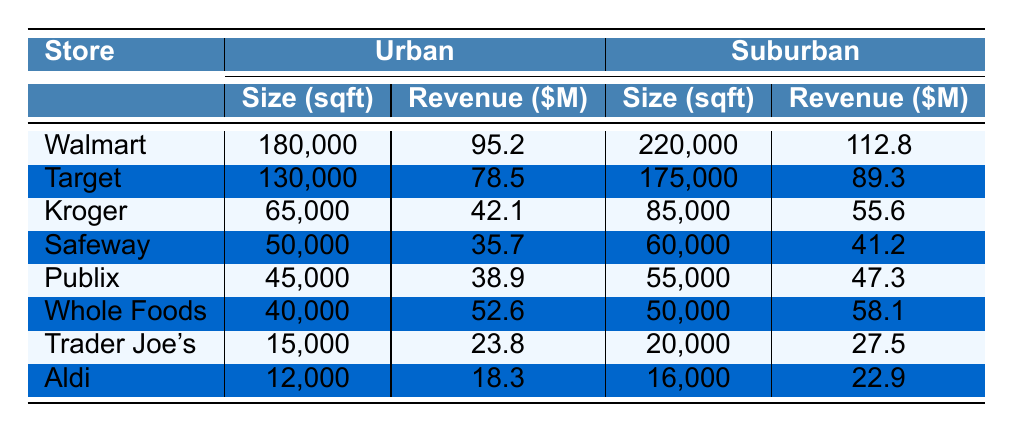What is the annual revenue of Walmart in an urban location? From the table, Walmart's annual revenue in an urban location is listed as 95.2 million dollars.
Answer: 95.2 million dollars What is the size of Target stores in suburban areas? The table shows that Target stores in suburban areas have a size of 175,000 square feet.
Answer: 175,000 square feet Which suburban store has the highest annual revenue? By examining the table, Walmart in suburban areas has the highest annual revenue of 112.8 million dollars compared to the other stores listed.
Answer: Walmart with 112.8 million dollars What is the difference in size between Kroger's urban and suburban stores? The size of Kroger's urban store is 65,000 square feet and the suburban store is 85,000 square feet. The difference is 85,000 - 65,000 = 20,000 square feet.
Answer: 20,000 square feet What is the average size of stores in urban locations? The sizes for the urban stores are: 180,000, 130,000, 65,000, 50,000, 45,000, 40,000, 15,000, and 12,000 square feet. Summing these gives 180,000 + 130,000 + 65,000 + 50,000 + 45,000 + 40,000 + 15,000 + 12,000 = 532,000 square feet. There are 8 stores, so the average size is 532,000 / 8 = 66,500 square feet.
Answer: 66,500 square feet Is there any store with the same size in both urban and suburban areas? By analyzing the table, no store has the same size listed for both locations; all values differ.
Answer: No Which store has the least annual revenue in urban areas? The table indicates that Aldi has the least annual revenue in urban areas at 18.3 million dollars.
Answer: Aldi with 18.3 million dollars What is the median store size in suburban areas? The sizes for suburban stores are 220,000, 175,000, 85,000, 60,000, 55,000, 50,000, 20,000, and 16,000 square feet. Arranging the sizes in ascending order gives: 16,000, 20,000, 50,000, 55,000, 60,000, 85,000, 175,000, 220,000. With an even number of entries, the median is the average of the 4th and 5th sizes: (55,000 + 60,000) / 2 = 57,500 square feet.
Answer: 57,500 square feet What is the total annual revenue from suburban stores? The revenues from suburban stores are 112.8, 89.3, 55.6, 41.2, 47.3, 58.1, 27.5, and 22.9 million dollars. Adding these gives 112.8 + 89.3 + 55.6 + 41.2 + 47.3 + 58.1 + 27.5 + 22.9 = 403.7 million dollars.
Answer: 403.7 million dollars Which urban store has the highest ratio of revenue to store size? The revenue-to-size ratios can be calculated as follows: Walmart: 95.2 / 180,000, Target: 78.5 / 130,000, Kroger: 42.1 / 65,000, Safeway: 35.7 / 50,000, Publix: 38.9 / 45,000, Whole Foods: 52.6 / 40,000, Trader Joe's: 23.8 / 15,000, Aldi: 18.3 / 12,000. After calculating, Trader Joe's has the highest ratio of approximately 1.59 (23.8 / 15,000).
Answer: Trader Joe's What is the total size of urban stores compared to suburban stores? Adding the sizes for urban stores yields 532,000 square feet and for suburban stores yields 1,006,000 square feet. Thus, suburban stores are larger: 1,006,000 - 532,000 = 474,000 square feet larger.
Answer: 474,000 square feet larger 